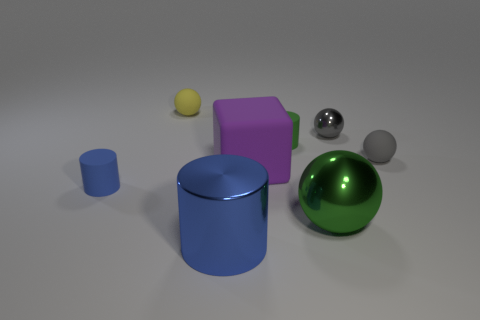How many objects are there in the image, and can you describe their colors and shapes? In the image, there are five objects. Starting from the left, there's a small yellow sphere, a tiny blue cylinder, a large purple cube, a shiny silver sphere, and a large green sphere with a glossy finish. The shapes represented are spherical and cuboidal, offering a visual diversity in both color and form. Which of these objects appears to reflect the most light? The shiny silver sphere appears to reflect the most light, indicating a highly reflective, possibly metallic surface. Its high gloss finish stands out against the more matte textures of the other objects. 